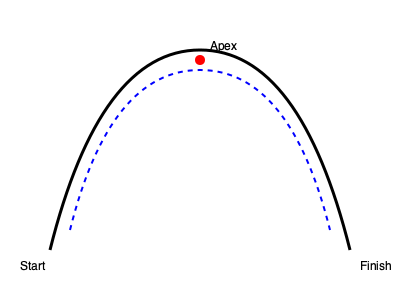Using the track diagram provided, describe a step-by-step mental imagery technique for visualizing the ideal racing line, focusing on the apex point and entry/exit strategies. How would this visualization contribute to managing race-day pressure? 1. Start with deep breathing to calm the mind and focus attention.

2. Visualize the starting position:
   - Imagine yourself in the car at the starting line
   - Feel the vibrations of the engine and grip on the steering wheel

3. Mental walk-through of the turn:
   a. Entry phase:
      - Visualize approaching the turn at high speed
      - Imagine the optimal braking point and gradually easing off the throttle
   b. Turn-in phase:
      - Picture smoothly turning the steering wheel towards the apex
      - Visualize the car's weight shifting as you enter the turn

4. Apex visualization:
   - Focus on the red dot representing the apex in the diagram
   - Imagine clipping this point precisely with your inside wheels
   - Visualize the sensation of G-forces at this moment

5. Exit strategy:
   - Picture gradually unwinding the steering wheel
   - Visualize accelerating out of the turn, following the blue dotted line
   - Imagine the feeling of the car gaining speed as it straightens out

6. Repeat the process:
   - Mentally go through this sequence multiple times
   - Each time, focus on perfecting a different aspect (entry speed, apex precision, exit acceleration)

7. Pressure management:
   - This visualization technique helps manage race-day pressure by:
     a. Increasing familiarity with the track, reducing uncertainty
     b. Building confidence through mental rehearsal
     c. Focusing the mind on the task, reducing anxiety
     d. Creating a sense of control over the racing process

8. Anchoring the visualization:
   - Associate this mental image with a physical cue (e.g., touching the steering wheel)
   - Use this anchor to quickly recall the visualization during the actual race

By repeatedly practicing this mental imagery technique, a NASCAR driver can improve their performance and better manage race-day pressure through increased focus, confidence, and a sense of preparedness.
Answer: Visualize: Start line, entry, apex (red dot), exit (blue line). Repeat, focusing on perfection. Use as a calming, focusing tool to manage pressure. 